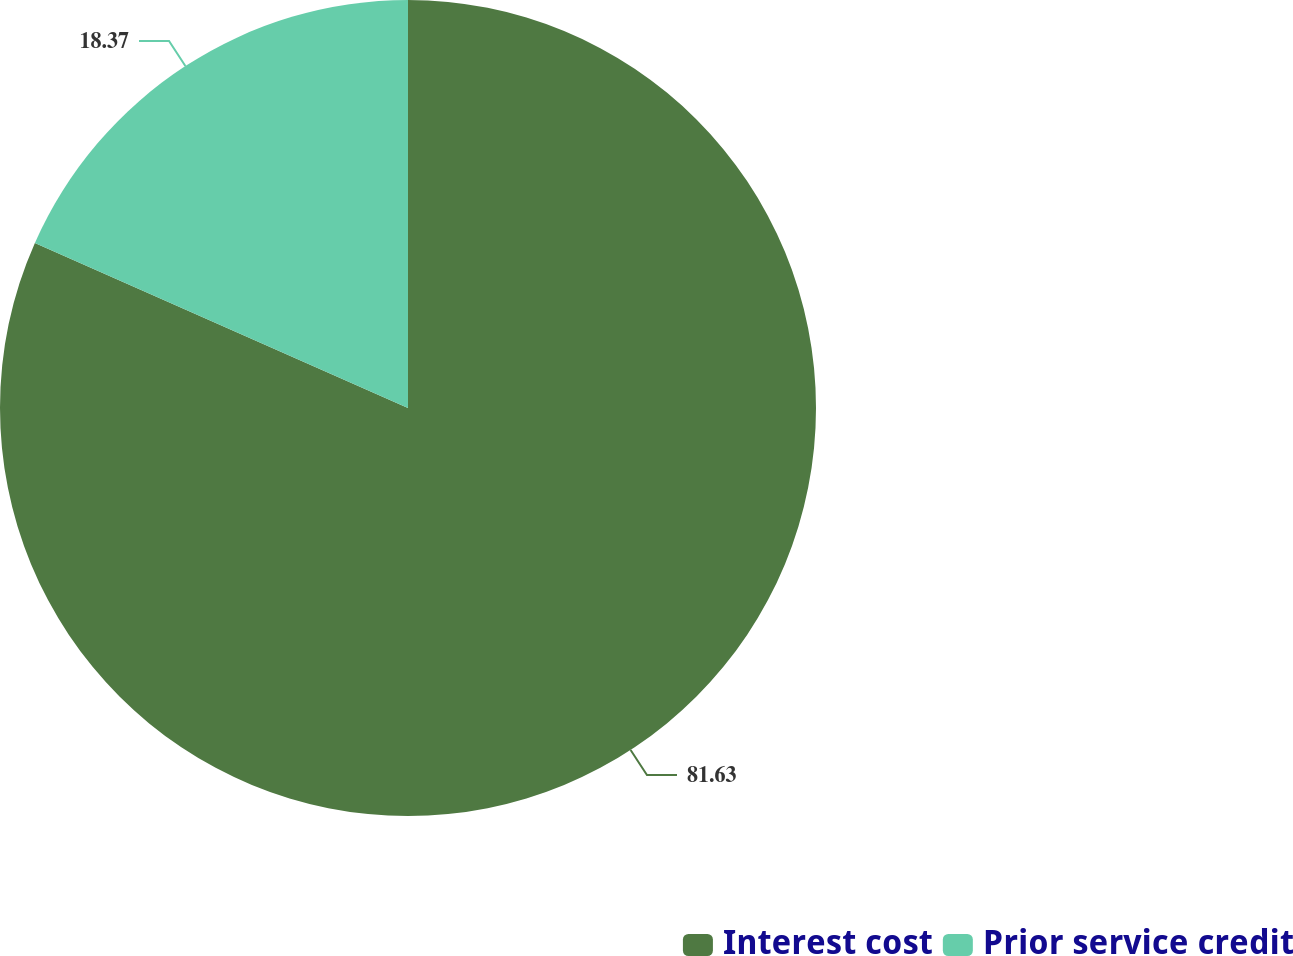Convert chart to OTSL. <chart><loc_0><loc_0><loc_500><loc_500><pie_chart><fcel>Interest cost<fcel>Prior service credit<nl><fcel>81.63%<fcel>18.37%<nl></chart> 